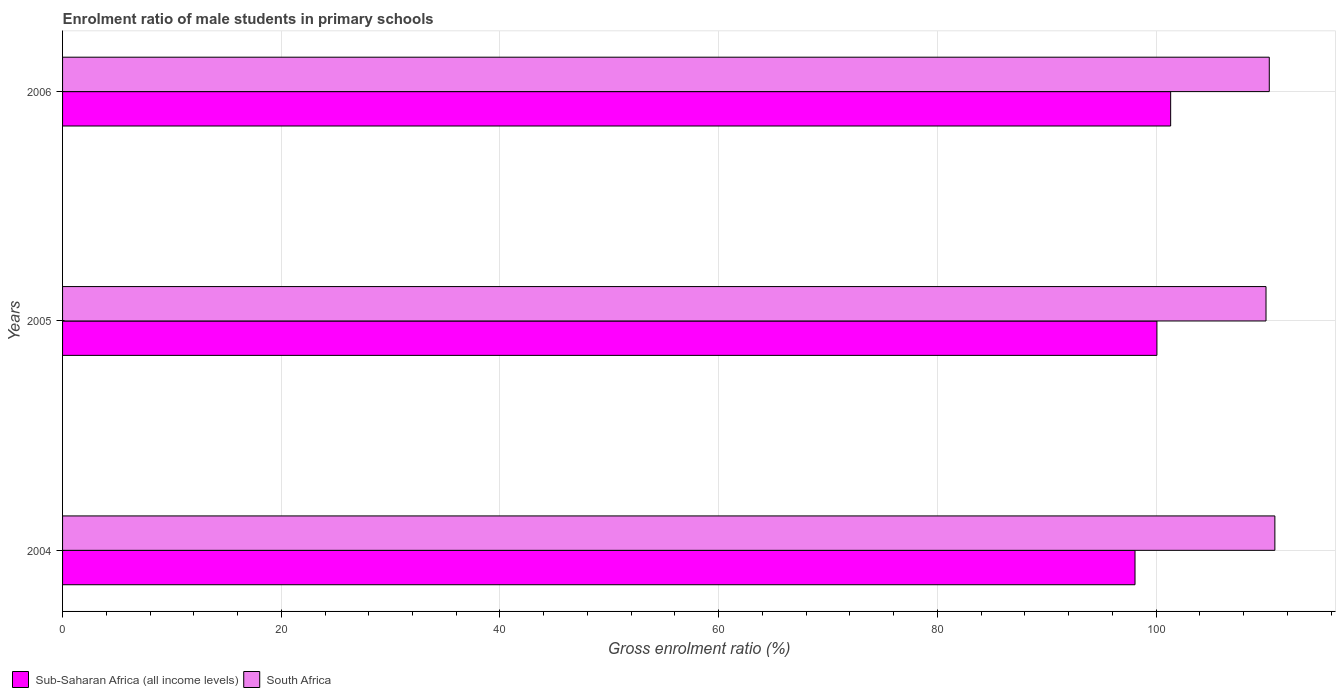How many different coloured bars are there?
Provide a succinct answer. 2. Are the number of bars on each tick of the Y-axis equal?
Your response must be concise. Yes. How many bars are there on the 1st tick from the top?
Offer a very short reply. 2. How many bars are there on the 1st tick from the bottom?
Ensure brevity in your answer.  2. What is the enrolment ratio of male students in primary schools in South Africa in 2004?
Make the answer very short. 110.86. Across all years, what is the maximum enrolment ratio of male students in primary schools in South Africa?
Offer a very short reply. 110.86. Across all years, what is the minimum enrolment ratio of male students in primary schools in South Africa?
Provide a short and direct response. 110.05. In which year was the enrolment ratio of male students in primary schools in South Africa maximum?
Ensure brevity in your answer.  2004. In which year was the enrolment ratio of male students in primary schools in Sub-Saharan Africa (all income levels) minimum?
Provide a short and direct response. 2004. What is the total enrolment ratio of male students in primary schools in Sub-Saharan Africa (all income levels) in the graph?
Provide a succinct answer. 299.48. What is the difference between the enrolment ratio of male students in primary schools in South Africa in 2004 and that in 2005?
Offer a very short reply. 0.81. What is the difference between the enrolment ratio of male students in primary schools in Sub-Saharan Africa (all income levels) in 2004 and the enrolment ratio of male students in primary schools in South Africa in 2005?
Ensure brevity in your answer.  -11.98. What is the average enrolment ratio of male students in primary schools in Sub-Saharan Africa (all income levels) per year?
Ensure brevity in your answer.  99.83. In the year 2005, what is the difference between the enrolment ratio of male students in primary schools in South Africa and enrolment ratio of male students in primary schools in Sub-Saharan Africa (all income levels)?
Your response must be concise. 9.98. What is the ratio of the enrolment ratio of male students in primary schools in South Africa in 2004 to that in 2005?
Offer a terse response. 1.01. Is the difference between the enrolment ratio of male students in primary schools in South Africa in 2005 and 2006 greater than the difference between the enrolment ratio of male students in primary schools in Sub-Saharan Africa (all income levels) in 2005 and 2006?
Keep it short and to the point. Yes. What is the difference between the highest and the second highest enrolment ratio of male students in primary schools in South Africa?
Your response must be concise. 0.51. What is the difference between the highest and the lowest enrolment ratio of male students in primary schools in South Africa?
Your answer should be very brief. 0.81. What does the 2nd bar from the top in 2005 represents?
Make the answer very short. Sub-Saharan Africa (all income levels). What does the 1st bar from the bottom in 2004 represents?
Offer a very short reply. Sub-Saharan Africa (all income levels). Are all the bars in the graph horizontal?
Offer a terse response. Yes. Are the values on the major ticks of X-axis written in scientific E-notation?
Your response must be concise. No. Does the graph contain any zero values?
Offer a terse response. No. What is the title of the graph?
Offer a terse response. Enrolment ratio of male students in primary schools. Does "Caribbean small states" appear as one of the legend labels in the graph?
Keep it short and to the point. No. What is the label or title of the X-axis?
Offer a terse response. Gross enrolment ratio (%). What is the Gross enrolment ratio (%) of Sub-Saharan Africa (all income levels) in 2004?
Your answer should be compact. 98.07. What is the Gross enrolment ratio (%) in South Africa in 2004?
Your answer should be very brief. 110.86. What is the Gross enrolment ratio (%) of Sub-Saharan Africa (all income levels) in 2005?
Your answer should be compact. 100.08. What is the Gross enrolment ratio (%) in South Africa in 2005?
Provide a short and direct response. 110.05. What is the Gross enrolment ratio (%) in Sub-Saharan Africa (all income levels) in 2006?
Your answer should be very brief. 101.33. What is the Gross enrolment ratio (%) in South Africa in 2006?
Provide a short and direct response. 110.35. Across all years, what is the maximum Gross enrolment ratio (%) of Sub-Saharan Africa (all income levels)?
Keep it short and to the point. 101.33. Across all years, what is the maximum Gross enrolment ratio (%) in South Africa?
Make the answer very short. 110.86. Across all years, what is the minimum Gross enrolment ratio (%) of Sub-Saharan Africa (all income levels)?
Your response must be concise. 98.07. Across all years, what is the minimum Gross enrolment ratio (%) of South Africa?
Make the answer very short. 110.05. What is the total Gross enrolment ratio (%) of Sub-Saharan Africa (all income levels) in the graph?
Your answer should be very brief. 299.48. What is the total Gross enrolment ratio (%) in South Africa in the graph?
Keep it short and to the point. 331.27. What is the difference between the Gross enrolment ratio (%) in Sub-Saharan Africa (all income levels) in 2004 and that in 2005?
Provide a succinct answer. -2. What is the difference between the Gross enrolment ratio (%) of South Africa in 2004 and that in 2005?
Ensure brevity in your answer.  0.81. What is the difference between the Gross enrolment ratio (%) of Sub-Saharan Africa (all income levels) in 2004 and that in 2006?
Your answer should be very brief. -3.26. What is the difference between the Gross enrolment ratio (%) of South Africa in 2004 and that in 2006?
Keep it short and to the point. 0.51. What is the difference between the Gross enrolment ratio (%) of Sub-Saharan Africa (all income levels) in 2005 and that in 2006?
Provide a succinct answer. -1.26. What is the difference between the Gross enrolment ratio (%) in South Africa in 2005 and that in 2006?
Your response must be concise. -0.3. What is the difference between the Gross enrolment ratio (%) of Sub-Saharan Africa (all income levels) in 2004 and the Gross enrolment ratio (%) of South Africa in 2005?
Keep it short and to the point. -11.98. What is the difference between the Gross enrolment ratio (%) of Sub-Saharan Africa (all income levels) in 2004 and the Gross enrolment ratio (%) of South Africa in 2006?
Provide a succinct answer. -12.28. What is the difference between the Gross enrolment ratio (%) of Sub-Saharan Africa (all income levels) in 2005 and the Gross enrolment ratio (%) of South Africa in 2006?
Ensure brevity in your answer.  -10.28. What is the average Gross enrolment ratio (%) in Sub-Saharan Africa (all income levels) per year?
Keep it short and to the point. 99.83. What is the average Gross enrolment ratio (%) in South Africa per year?
Give a very brief answer. 110.42. In the year 2004, what is the difference between the Gross enrolment ratio (%) in Sub-Saharan Africa (all income levels) and Gross enrolment ratio (%) in South Africa?
Provide a succinct answer. -12.79. In the year 2005, what is the difference between the Gross enrolment ratio (%) in Sub-Saharan Africa (all income levels) and Gross enrolment ratio (%) in South Africa?
Your response must be concise. -9.98. In the year 2006, what is the difference between the Gross enrolment ratio (%) of Sub-Saharan Africa (all income levels) and Gross enrolment ratio (%) of South Africa?
Your answer should be very brief. -9.02. What is the ratio of the Gross enrolment ratio (%) in South Africa in 2004 to that in 2005?
Provide a short and direct response. 1.01. What is the ratio of the Gross enrolment ratio (%) in Sub-Saharan Africa (all income levels) in 2004 to that in 2006?
Your response must be concise. 0.97. What is the ratio of the Gross enrolment ratio (%) of Sub-Saharan Africa (all income levels) in 2005 to that in 2006?
Give a very brief answer. 0.99. What is the difference between the highest and the second highest Gross enrolment ratio (%) of Sub-Saharan Africa (all income levels)?
Keep it short and to the point. 1.26. What is the difference between the highest and the second highest Gross enrolment ratio (%) in South Africa?
Ensure brevity in your answer.  0.51. What is the difference between the highest and the lowest Gross enrolment ratio (%) in Sub-Saharan Africa (all income levels)?
Keep it short and to the point. 3.26. What is the difference between the highest and the lowest Gross enrolment ratio (%) in South Africa?
Your answer should be compact. 0.81. 